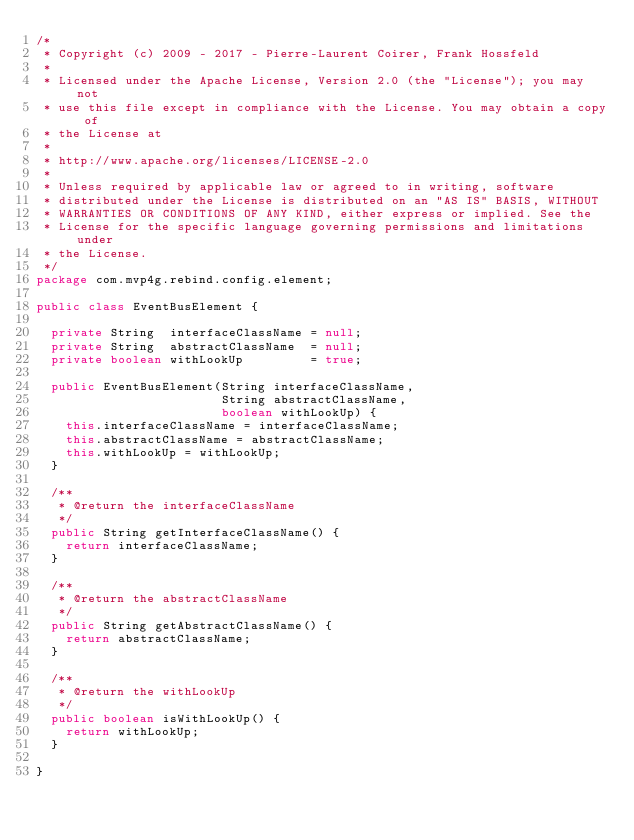<code> <loc_0><loc_0><loc_500><loc_500><_Java_>/*
 * Copyright (c) 2009 - 2017 - Pierre-Laurent Coirer, Frank Hossfeld
 *
 * Licensed under the Apache License, Version 2.0 (the "License"); you may not
 * use this file except in compliance with the License. You may obtain a copy of
 * the License at
 *
 * http://www.apache.org/licenses/LICENSE-2.0
 *
 * Unless required by applicable law or agreed to in writing, software
 * distributed under the License is distributed on an "AS IS" BASIS, WITHOUT
 * WARRANTIES OR CONDITIONS OF ANY KIND, either express or implied. See the
 * License for the specific language governing permissions and limitations under
 * the License.
 */
package com.mvp4g.rebind.config.element;

public class EventBusElement {

  private String  interfaceClassName = null;
  private String  abstractClassName  = null;
  private boolean withLookUp         = true;

  public EventBusElement(String interfaceClassName,
                         String abstractClassName,
                         boolean withLookUp) {
    this.interfaceClassName = interfaceClassName;
    this.abstractClassName = abstractClassName;
    this.withLookUp = withLookUp;
  }

  /**
   * @return the interfaceClassName
   */
  public String getInterfaceClassName() {
    return interfaceClassName;
  }

  /**
   * @return the abstractClassName
   */
  public String getAbstractClassName() {
    return abstractClassName;
  }

  /**
   * @return the withLookUp
   */
  public boolean isWithLookUp() {
    return withLookUp;
  }

}
</code> 